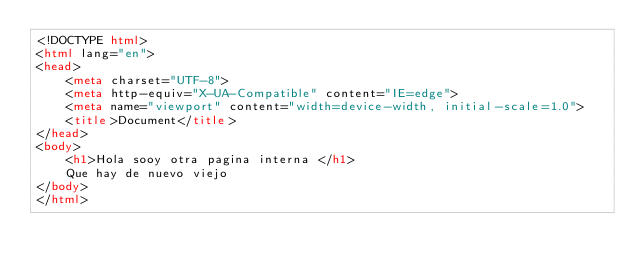<code> <loc_0><loc_0><loc_500><loc_500><_HTML_><!DOCTYPE html>
<html lang="en">
<head>
    <meta charset="UTF-8">
    <meta http-equiv="X-UA-Compatible" content="IE=edge">
    <meta name="viewport" content="width=device-width, initial-scale=1.0">
    <title>Document</title>
</head>
<body>
    <h1>Hola sooy otra pagina interna </h1>
    Que hay de nuevo viejo
</body>
</html></code> 